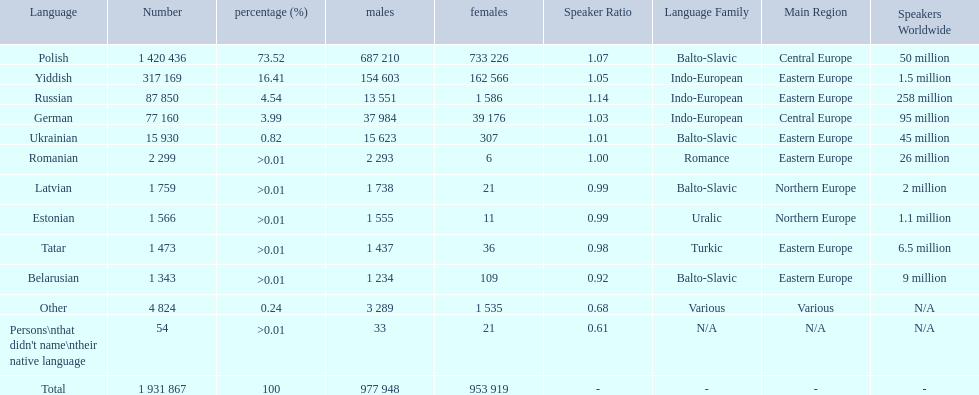How many languages are shown? Polish, Yiddish, Russian, German, Ukrainian, Romanian, Latvian, Estonian, Tatar, Belarusian, Other. What language is in third place? Russian. What language is the most spoken after that one? German. 